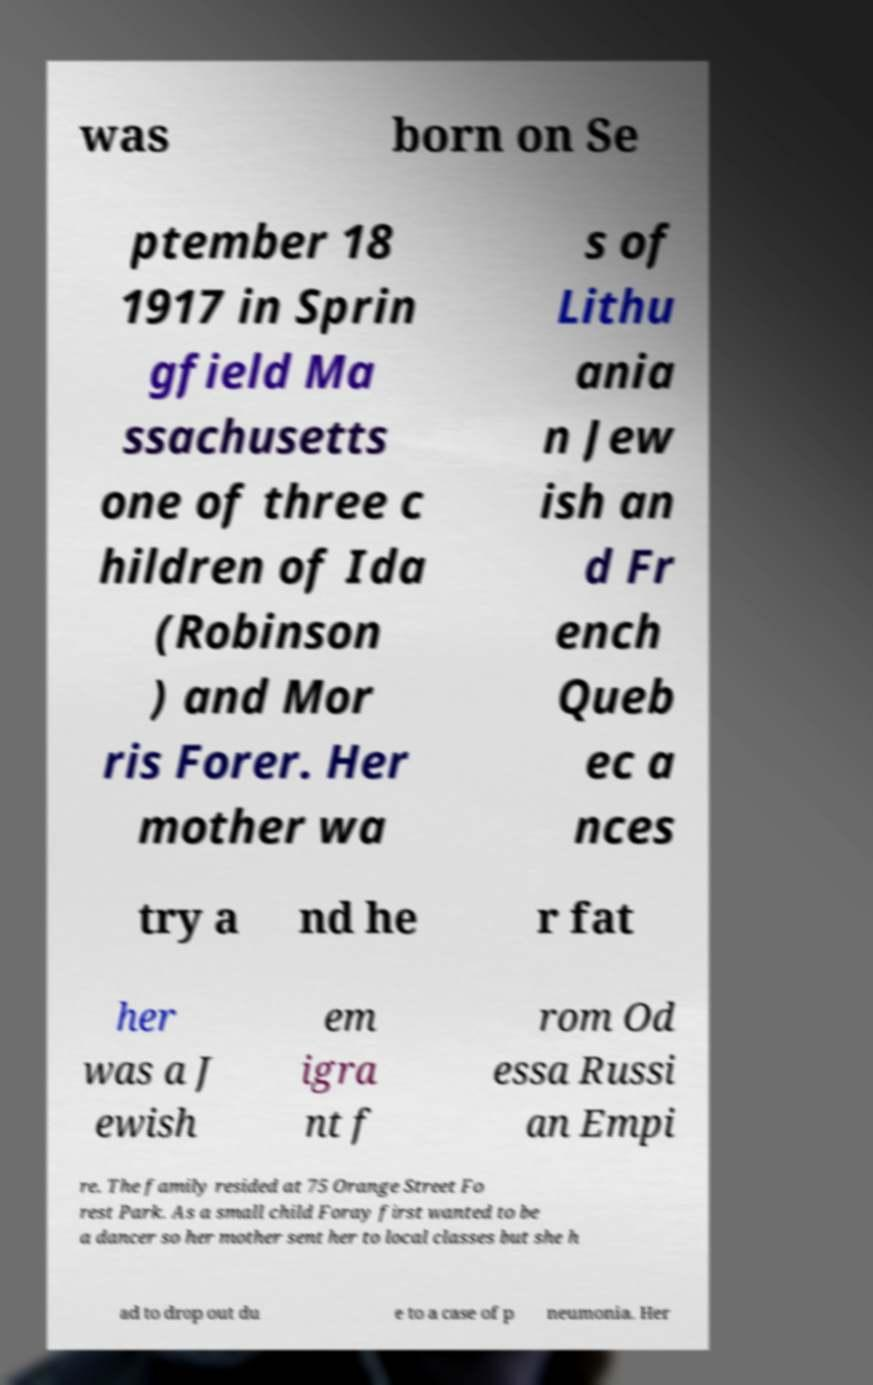Could you assist in decoding the text presented in this image and type it out clearly? was born on Se ptember 18 1917 in Sprin gfield Ma ssachusetts one of three c hildren of Ida (Robinson ) and Mor ris Forer. Her mother wa s of Lithu ania n Jew ish an d Fr ench Queb ec a nces try a nd he r fat her was a J ewish em igra nt f rom Od essa Russi an Empi re. The family resided at 75 Orange Street Fo rest Park. As a small child Foray first wanted to be a dancer so her mother sent her to local classes but she h ad to drop out du e to a case of p neumonia. Her 